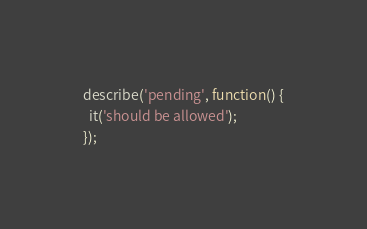<code> <loc_0><loc_0><loc_500><loc_500><_JavaScript_>
describe('pending', function() {
  it('should be allowed');
});
</code> 